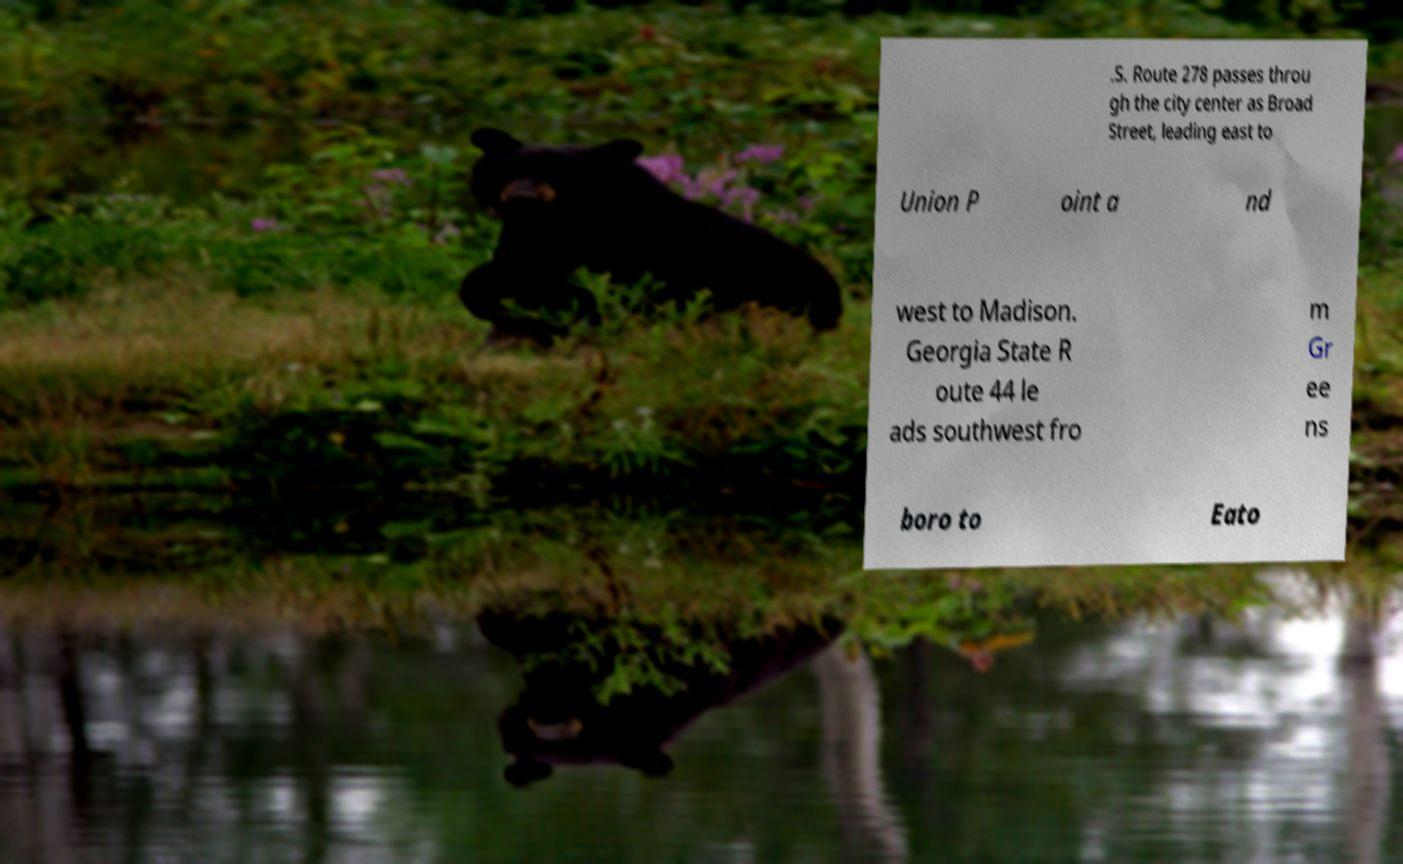What messages or text are displayed in this image? I need them in a readable, typed format. .S. Route 278 passes throu gh the city center as Broad Street, leading east to Union P oint a nd west to Madison. Georgia State R oute 44 le ads southwest fro m Gr ee ns boro to Eato 